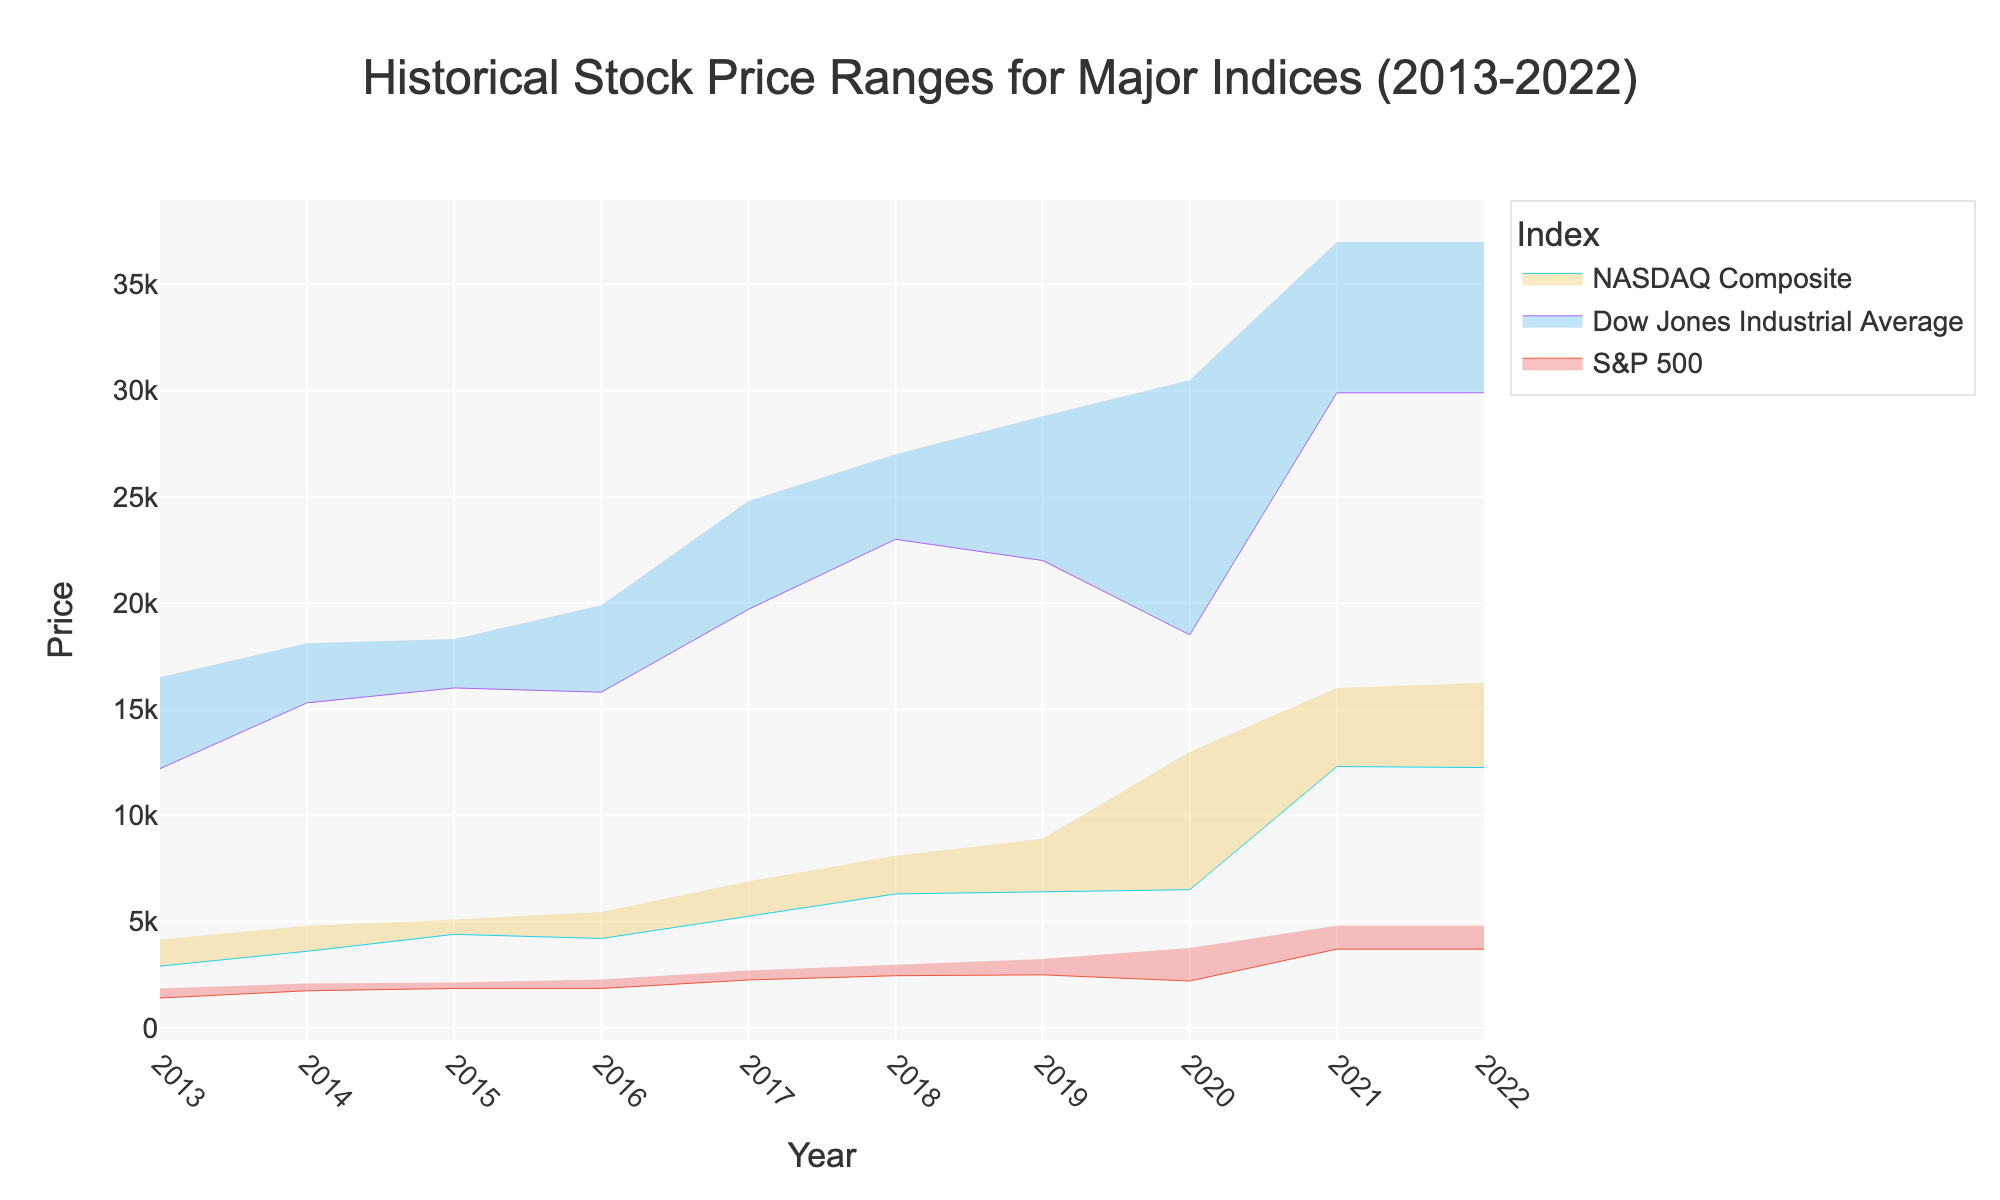What is the title of the figure? The title is shown at the top center of the figure in large, bold font. It describes the content of the chart.
Answer: Historical Stock Price Ranges for Major Indices (2013-2022) How many indices are shown in the chart? By examining the legend, you can see the different indices listed.
Answer: Three Which year had the highest maximum price for the NASDAQ Composite? Look at the NASDAQ Composite section and identify the year with the highest point on the upper boundary of the range.
Answer: 2021 Which index had the largest range in 2020? Compare the maximum and minimum prices for each index in 2020, then find the index with the largest difference. The range for each index is calculated as Maximum_Price - Minimum_Price. For S&P 500: 3750 - 2200 = 1550, Dow Jones: 30500 - 18500 = 12000, NASDAQ Composite: 13000 - 6500 = 6500.
Answer: Dow Jones Industrial Average From 2018 to 2019, did the minimum price of the S&P 500 increase or decrease? Compare the minimum prices of the S&P 500 in 2018 and 2019, which can be seen by looking at the lower boundary of the shaded area.
Answer: Increase Which index shows the most stable range over the past decade? Stability can be inferred by observing the consistency in the width of the shaded range across the years. If the range does not vary much in width, it indicates stability.
Answer: NASDAQ Composite What was the price range for the S&P 500 in 2017? To find the range, identify the minimum and maximum prices for the S&P 500 in 2017 by looking at the boundaries of the shaded area.
Answer: 2250 to 2700 Which year saw the smallest maximum stock price for the Dow Jones Industrial Average? Look at the maximum prices for the Dow Jones Industrial Average in each year and identify the smallest value.
Answer: 2013 Did the NASDAQ Composite reach a higher maximum price in 2021 or 2022? Compare the maximum prices of the NASDAQ Composite in 2021 and 2022 by looking at the highest points in those years.
Answer: 2022 Which index had the highest minimum price in 2020? Examine the minimum prices of each index for 2020 and identify the highest among them.
Answer: Dow Jones Industrial Average 